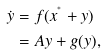Convert formula to latex. <formula><loc_0><loc_0><loc_500><loc_500>\dot { y } & = f ( x ^ { ^ { * } } + y ) \\ & = A y + g ( y ) ,</formula> 